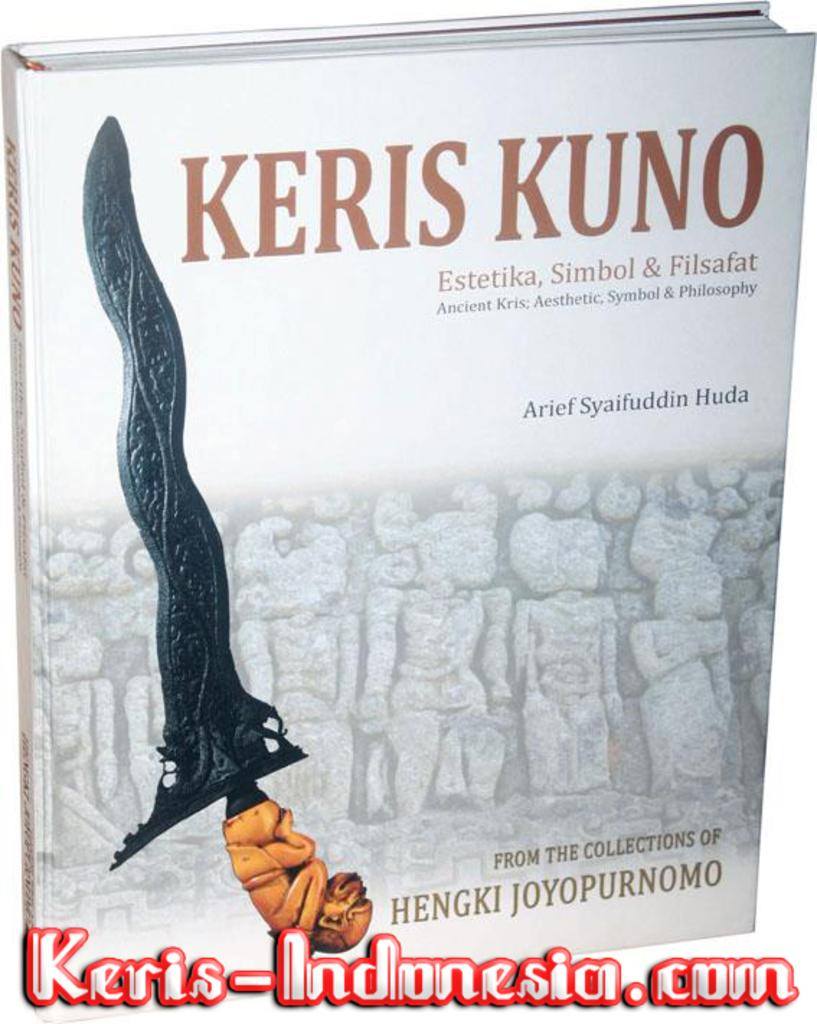What object can be seen in the image? There is a book in the image. What can be found on the book? There is text written on the book. How many eyes can be seen on the book in the image? There are no eyes present on the book in the image. Where is the lunchroom located in the image? There is no lunchroom present in the image; it only features a book with text on it. 